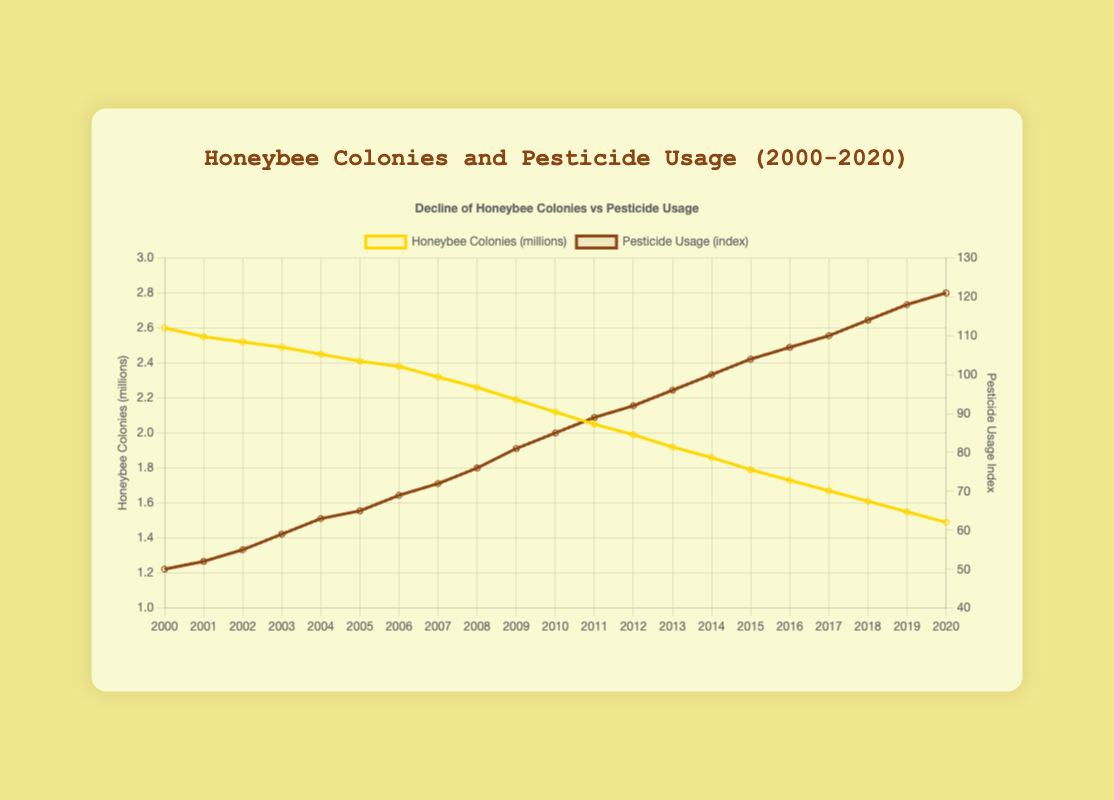How is the trend of honeybee colonies changing over the 20 years shown in the figure? The line representing honeybee colonies shows a clear declining trend over the 20-year period, starting from approximately 2.6 million colonies in 2000 to around 1.49 million colonies in 2020.
Answer: Declining What is the relationship between pesticide usage and honeybee colony numbers over the given years? As pesticide usage (brown line) increases from 50 in 2000 to 121 in 2020, the number of honeybee colonies (yellow line) decreases from 2.6 million to 1.49 million, indicating a possible negative relationship.
Answer: Negative relationship By how much did the honeybee colonies decrease from 2000 to 2010? The number of honeybee colonies decreased from 2.6 million in 2000 to 2.12 million in 2010. The difference is 2.6 - 2.12 = 0.48 million colonies.
Answer: 0.48 million What colors are used to represent honeybee colonies and pesticide usage, and which side of the y-axis do they correspond to? The yellow color represents honeybee colonies (left y-axis), and the brown color represents pesticide usage (right y-axis).
Answer: Yellow and brown During which year did pesticide usage first exceed 100? Pesticide usage first exceeded 100 in 2014, as shown by the brown line coinciding with the respective index on the right y-axis.
Answer: 2014 Compare the slope of the honeybee colonies trend line with the slope of the pesticide usage trend line. Which one is steeper? Visually comparing the two lines, the honeybee colonies decline line appears to be smoother and less steep compared to the consistently rising and steeper pesticide usage line.
Answer: Pesticide usage line Calculate the average annual decline in honeybee colonies from 2000 to 2020. The honeybee colonies decreased from 2.6 million to 1.49 million over 20 years. The average annual decline is (2.6 - 1.49) / 20 = 0.0555 million colonies per year.
Answer: 0.0555 million colonies per year By how much did pesticide usage increase from 2000 to 2010? Pesticide usage increased from 50 in 2000 to 85 in 2010. The change is 85 - 50 = 35.
Answer: 35 Which year saw the highest number of honeybee colonies, and which year saw the lowest based on the figure? The highest number of honeybee colonies was in 2000 (2.6 million), and the lowest was in 2020 (1.49 million).
Answer: 2000 and 2020 Is the decline in honeybee colonies consistent every year, or are there periods of stagnation or acceleration? The decline in honeybee colonies appears to be relatively consistent over the years with no sharp accelerations or periods of stagnation, showing a steady downward trend.
Answer: Consistent 